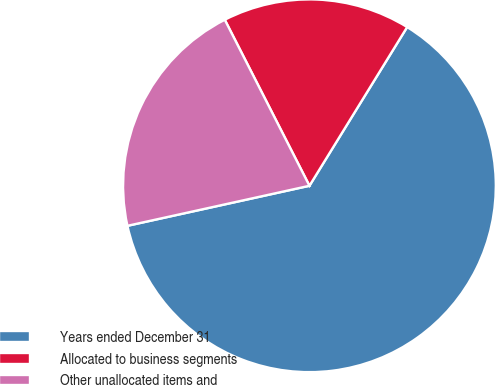Convert chart to OTSL. <chart><loc_0><loc_0><loc_500><loc_500><pie_chart><fcel>Years ended December 31<fcel>Allocated to business segments<fcel>Other unallocated items and<nl><fcel>62.77%<fcel>16.29%<fcel>20.94%<nl></chart> 